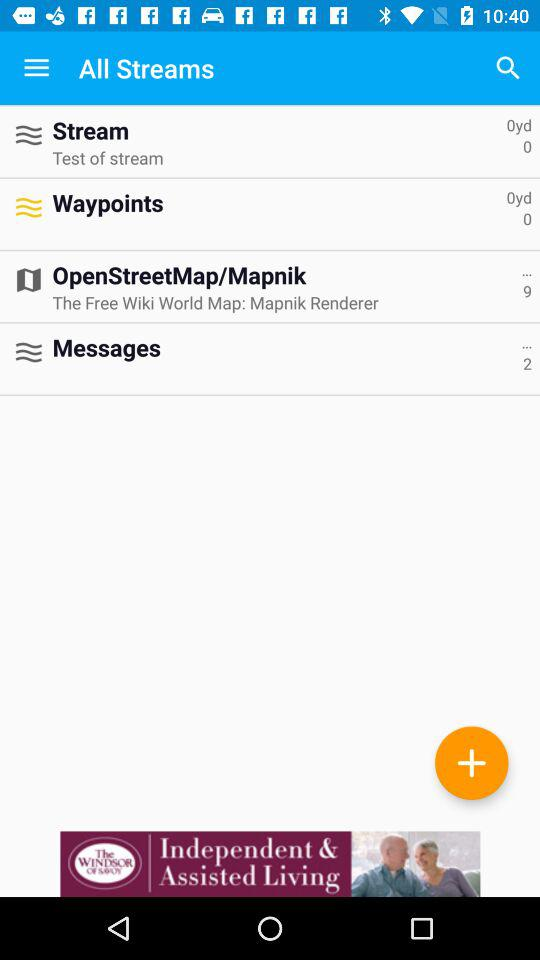How many messages are there? There are 2 messages. 